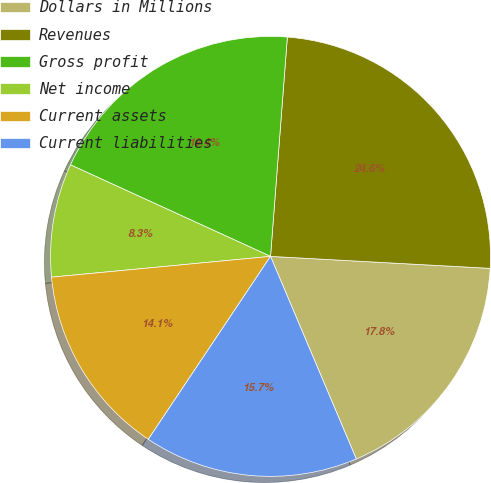Convert chart. <chart><loc_0><loc_0><loc_500><loc_500><pie_chart><fcel>Dollars in Millions<fcel>Revenues<fcel>Gross profit<fcel>Net income<fcel>Current assets<fcel>Current liabilities<nl><fcel>17.76%<fcel>24.65%<fcel>19.39%<fcel>8.34%<fcel>14.12%<fcel>15.75%<nl></chart> 